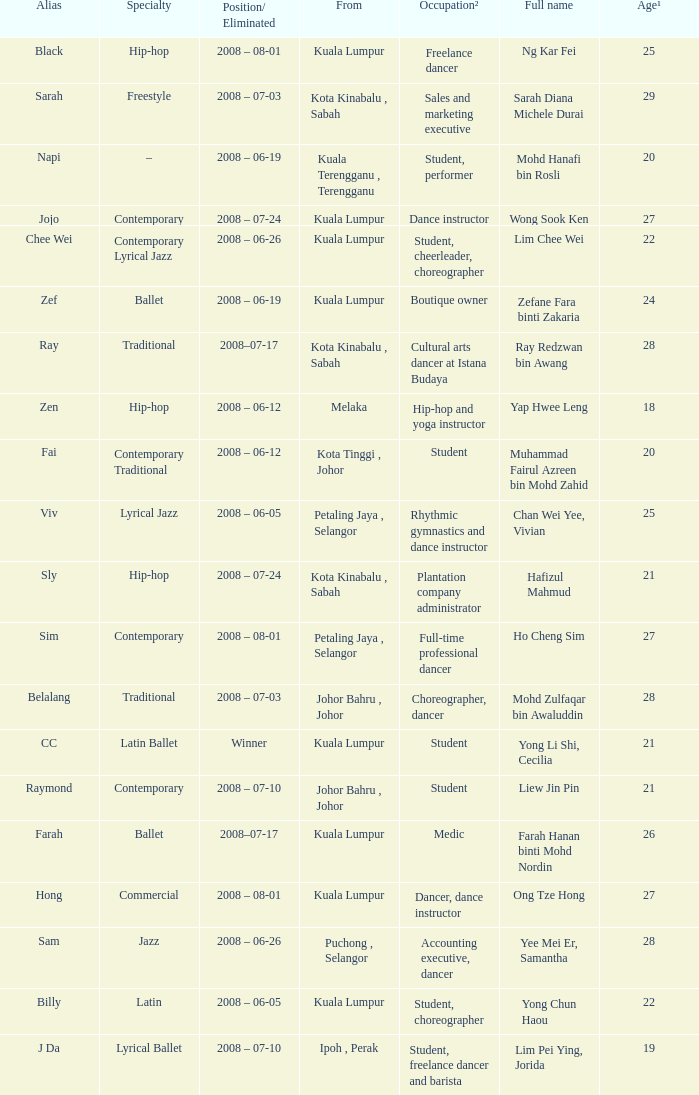What is Occupation², when Age¹ is greater than 24, when Alias is "Black"? Freelance dancer. 